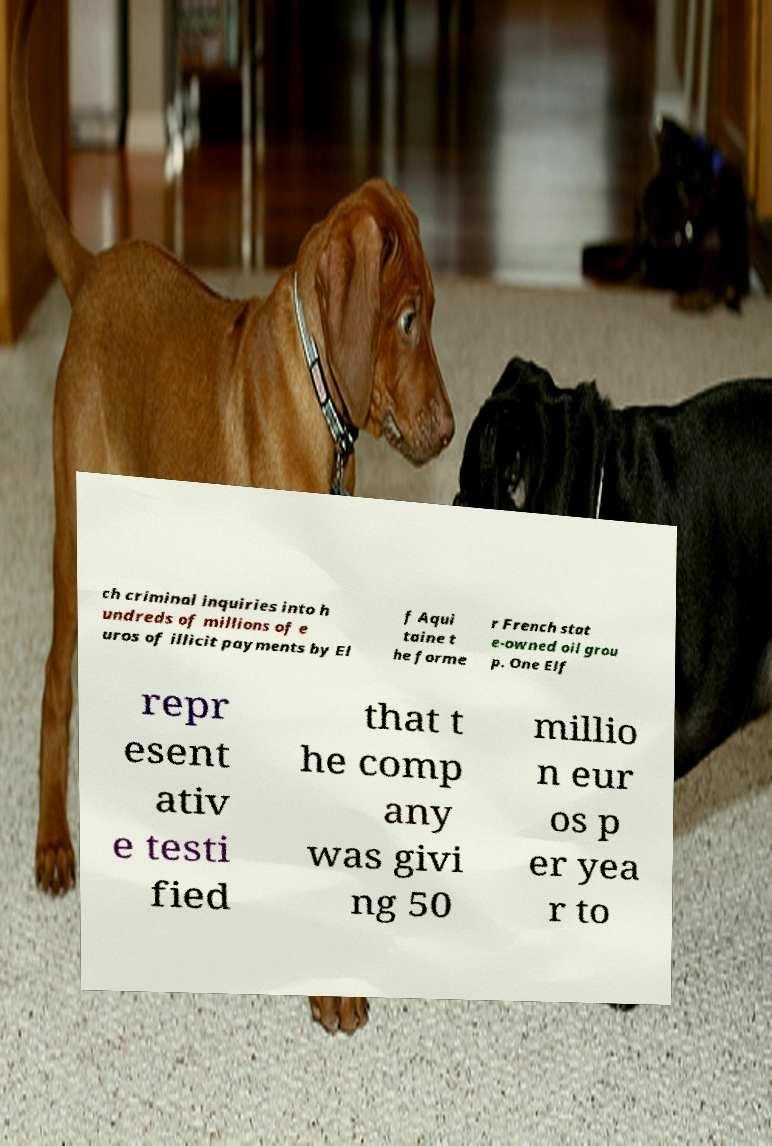Please identify and transcribe the text found in this image. ch criminal inquiries into h undreds of millions of e uros of illicit payments by El f Aqui taine t he forme r French stat e-owned oil grou p. One Elf repr esent ativ e testi fied that t he comp any was givi ng 50 millio n eur os p er yea r to 